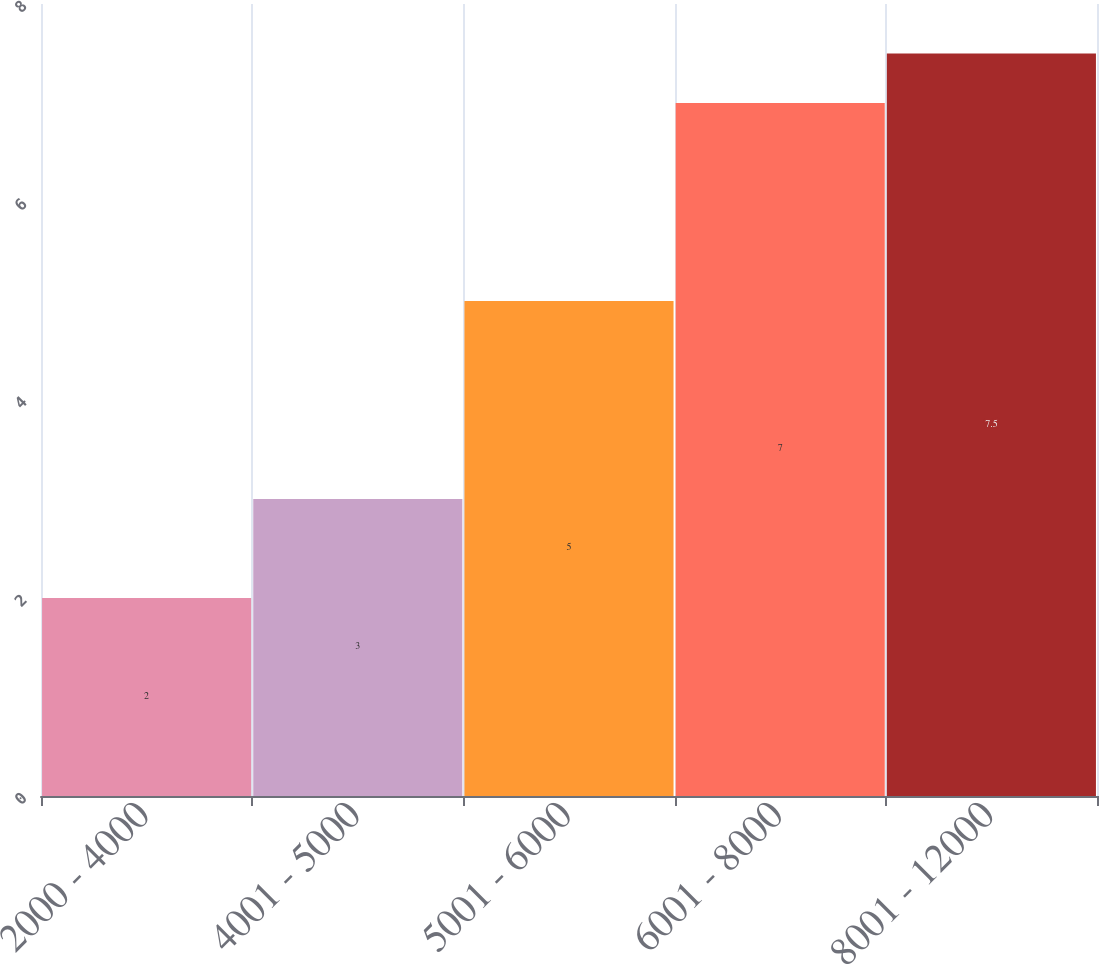Convert chart to OTSL. <chart><loc_0><loc_0><loc_500><loc_500><bar_chart><fcel>2000 - 4000<fcel>4001 - 5000<fcel>5001 - 6000<fcel>6001 - 8000<fcel>8001 - 12000<nl><fcel>2<fcel>3<fcel>5<fcel>7<fcel>7.5<nl></chart> 